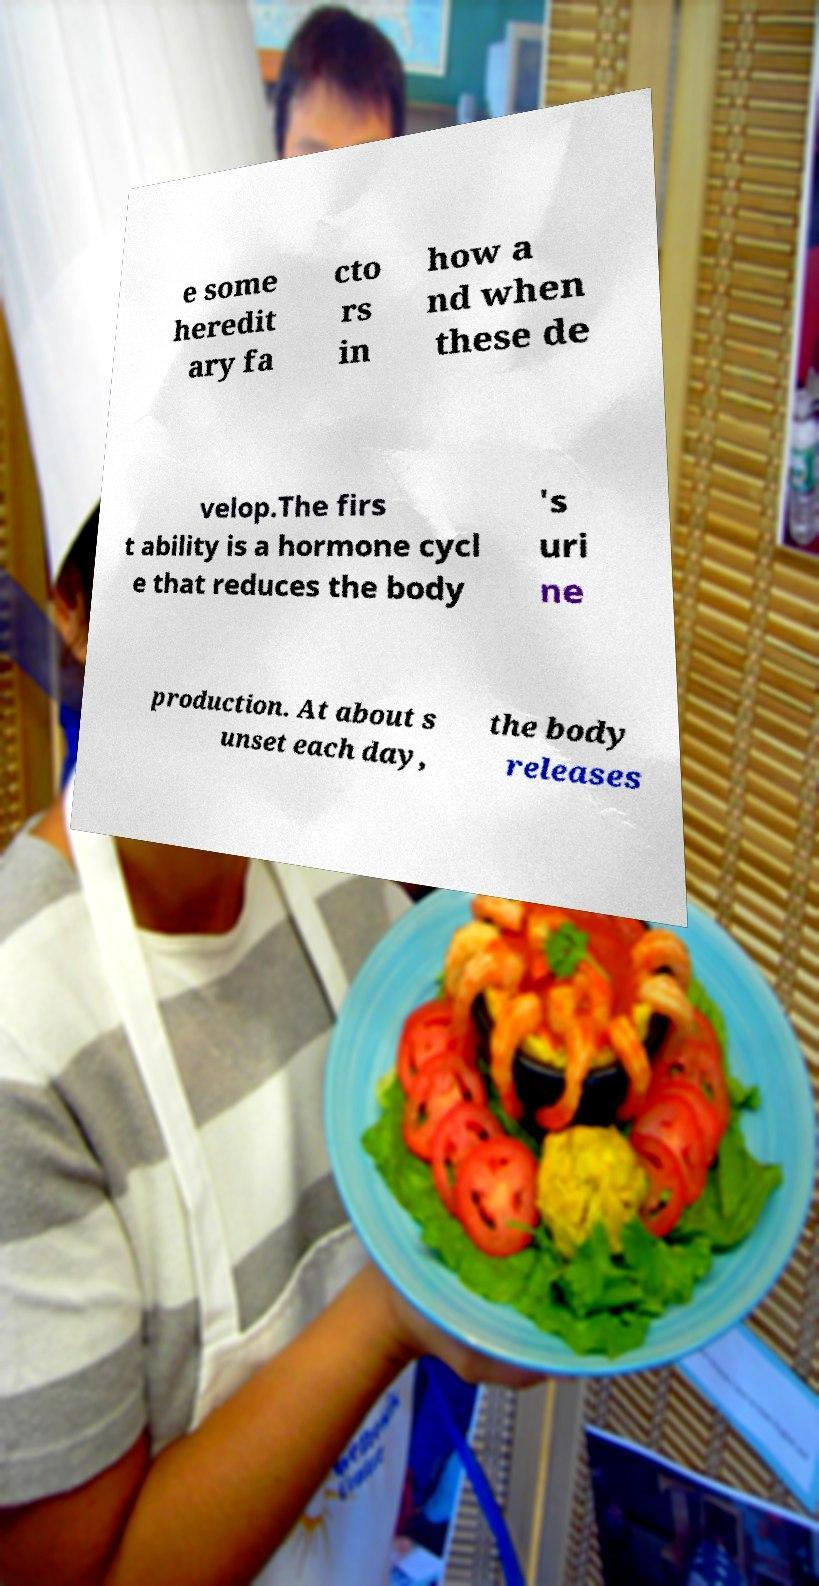There's text embedded in this image that I need extracted. Can you transcribe it verbatim? e some heredit ary fa cto rs in how a nd when these de velop.The firs t ability is a hormone cycl e that reduces the body 's uri ne production. At about s unset each day, the body releases 